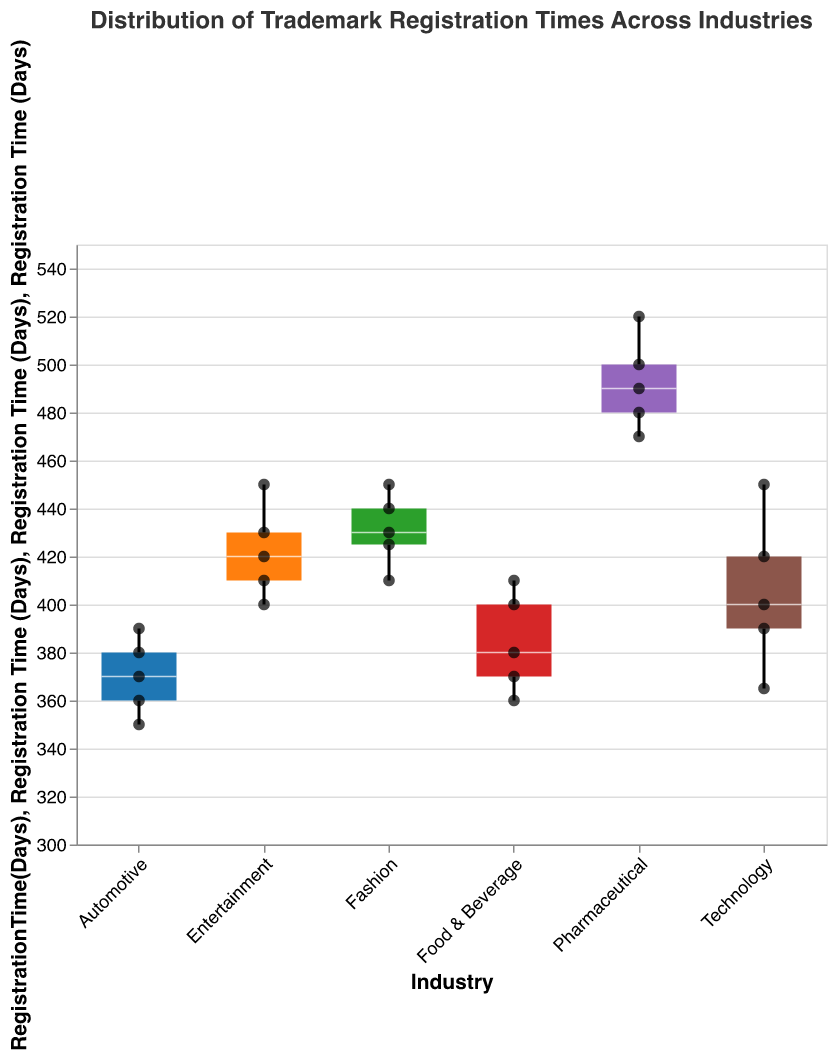What is the title of the figure? Look at the top of the figure to find the title.
Answer: Distribution of Trademark Registration Times Across Industries What does the y-axis represent? The label on the y-axis shows what is being measured.
Answer: Registration Time (Days) Which industry has the longest median registration time? The median is the line inside the box; compare the medians of all industries.
Answer: Pharmaceutical What is the interquartile range (IQR) for the Entertainment industry? The IQR is the difference between the upper and lower quartiles (the top and bottom of the box). Estimate these values for the Entertainment industry and subtract the lower from the upper.
Answer: 30 days (430-400) How many data points are there for the Technology industry? Count the number of scatter points in the Technology section.
Answer: 5 Which industry's trademarks take the least time to register, on average? Calculate the average registration time for each industry by summing their individual registration times and dividing by the number of data points, then compare.
Answer: Automotive What is the range of registration times for the Pharmaceutical industry? The range is the difference between the maximum and minimum registration times. For Pharmaceutical, this is the maximum point minus the minimum point.
Answer: 50 days (520-470) Are there any industries where all data points are above 400 days? Identify if any industry's minimum registration time is above 400 days by looking at the scatter points.
Answer: Pharmaceutical and Fashion Which industry shows the most variability in trademark registration times? Variability can be assessed by the range of the box plot (distance between the maximum and minimum points) and the spread of scatter points.
Answer: Pharmaceutical Which industry has the smallest median registration time, and what is it? Find the industry with the lowest line inside the box and read off the value.
Answer: Automotive, 370 days 